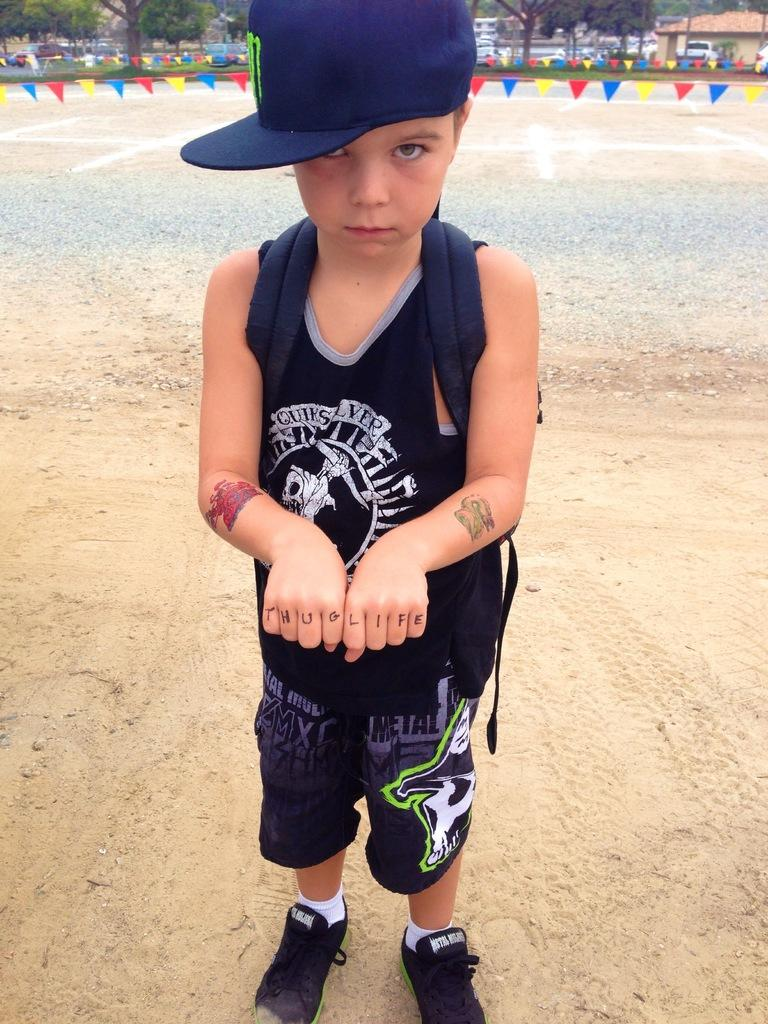Who is the main subject in the image? There is a boy in the image. What is the boy wearing on his head? The boy is wearing a cap. What can be seen in the background of the image? There are flags, vehicles, houses, and trees in the background of the image. How many pigs are present in the image? There are no pigs present in the image. What type of currency exchange is taking place in the image? There is no currency exchange or any financial transaction depicted in the image. 